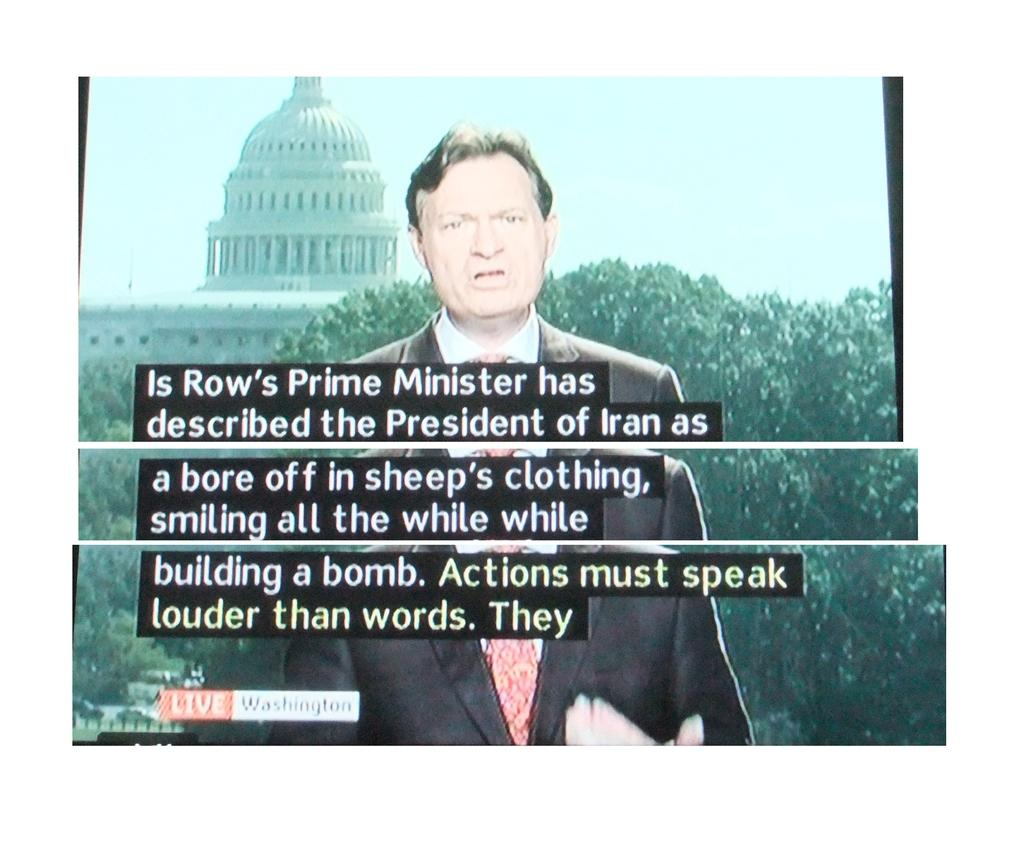What is the main subject of the image? There is a display screen of a news reader in the image. What else can be seen in the image besides the display screen? There are papers visible in the image, and text is present as well. What can be seen in the background of the image? There is a tree and a monument in the background of the image. What type of alarm is ringing in the image? There is no alarm present in the image. Can you describe the bulb used to illuminate the news reader's display screen? There is no specific mention of a bulb in the image; the display screen is the main focus. 